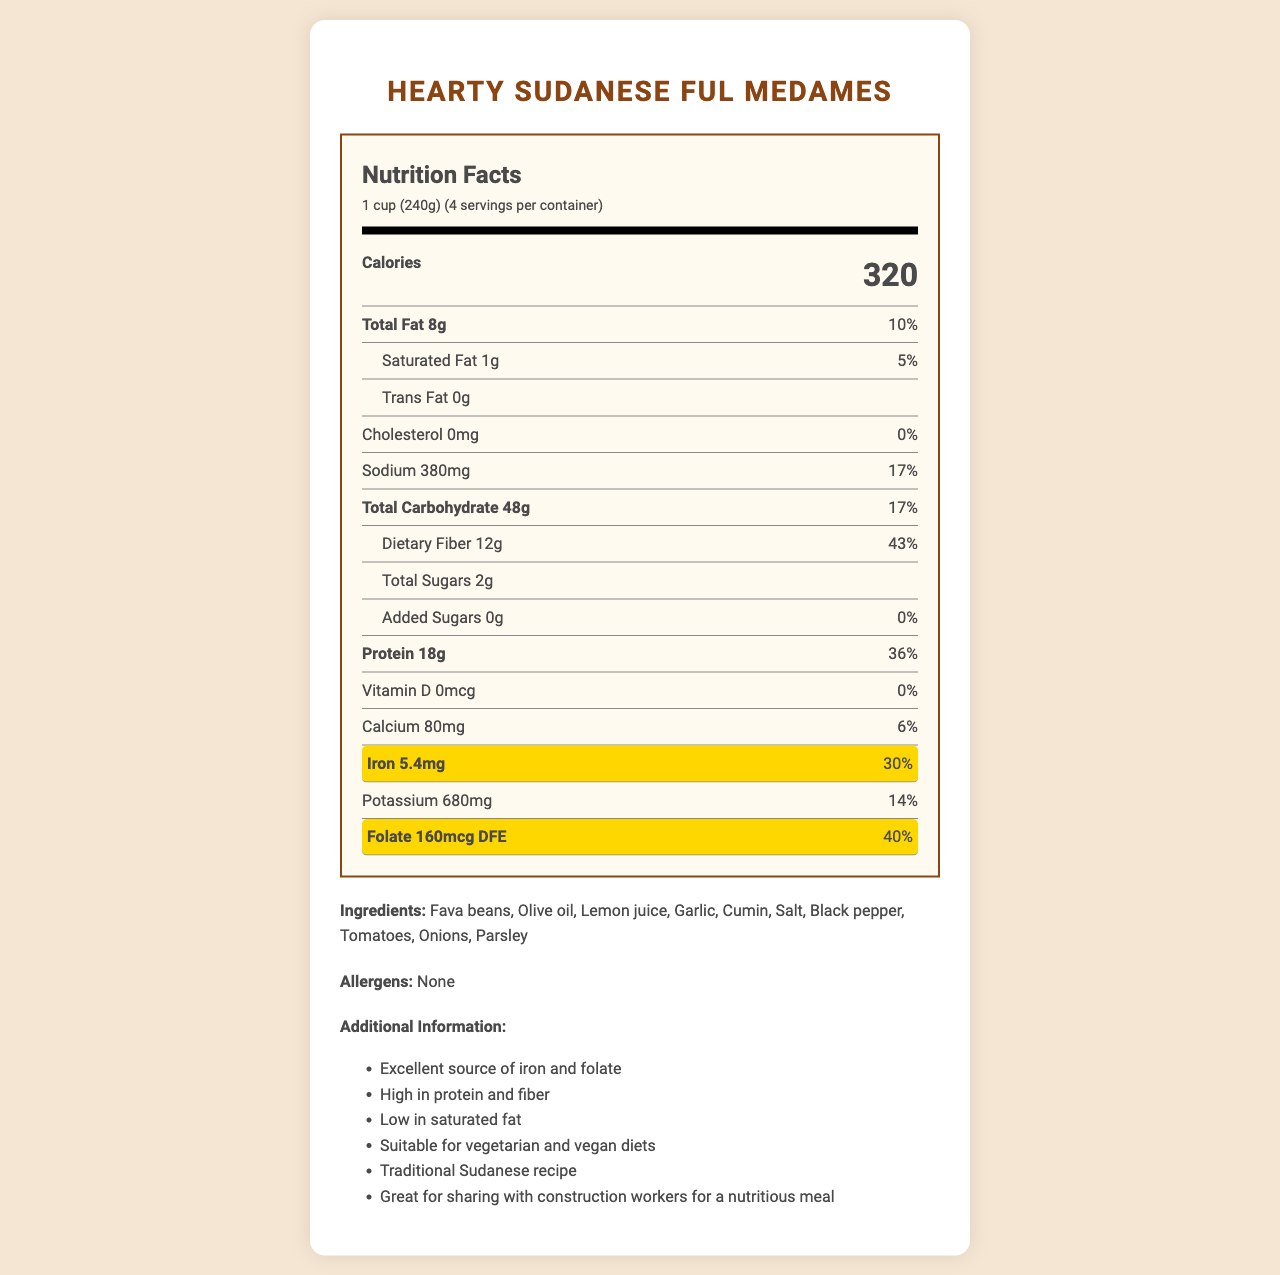What is the serving size of Hearty Sudanese Ful Medames? The serving size is specified in the serving information section at the top of the nutrition label.
Answer: 1 cup (240g) How many calories are in one serving? The calories per serving are listed prominently at the top of the nutrition label.
Answer: 320 What is the total fat content per serving? The total fat amount is listed in the nutrient breakdown under "Total Fat."
Answer: 8g How much iron does one serving provide? The iron content is highlighted in the nutrient section with a daily value of 30%.
Answer: 5.4mg What is the daily value percentage for folate in one serving? The daily value percentage for folate is clearly listed in the nutrient breakdown under "Folate."
Answer: 40% How many servings are in the entire container? The serving information specifies that there are 4 servings per container.
Answer: 4 True or False: This product contains added sugars. The nutritional label shows that added sugars are listed as 0g with a daily value of 0%.
Answer: False Which of the following ingredients is NOT listed in Hearty Sudanese Ful Medames? A. Garlic B. Chickpeas C. Lemon juice D. Salt The ingredient list includes garlic, lemon juice, and salt but does not mention chickpeas.
Answer: B. Chickpeas What is the primary benefit of this meal for construction workers? A. High protein content B. Contains added sugars C. High in saturated fat D. Contains trans fats One of the additional pieces of information highlights that this meal is high in protein, which is beneficial for demanding physical activities like construction work.
Answer: A. High protein content Does Hearty Sudanese Ful Medames contain any allergens? The allergens section clearly states "None."
Answer: No Summarize the key nutritional aspects and additional information of this document. This summary highlights the nutritional benefits, ingredients, dietary suitability, and additional information about the Hearty Sudanese Ful Medames provided in the document.
Answer: Hearty Sudanese Ful Medames is a nutritious meal that offers high amounts of iron and folate, making it particularly beneficial for individuals needing to increase these nutrients. It also provides a good amount of protein and dietary fiber while being low in saturated fat and free of trans fats and cholesterol. The ingredients are all plant-based, making the dish suitable for both vegetarian and vegan diets. Additional information emphasizes that it is a traditional Sudanese recipe and a great meal option for construction workers due to its nutritional profile. What are some traditional spices used in the recipe? The ingredients list includes cumin and black pepper as traditional spices used in the recipe.
Answer: Cumin, Black pepper How many grams of dietary fiber are in one serving? The dietary fiber content per serving is listed in the nutrient breakdown under "Dietary Fiber."
Answer: 12g Can you determine the exact preparation method of Hearty Sudanese Ful Medames from the document? The document provides nutritional information, ingredients, and some additional insights, but it does not include the specific preparation steps for making the dish.
Answer: Not enough information 